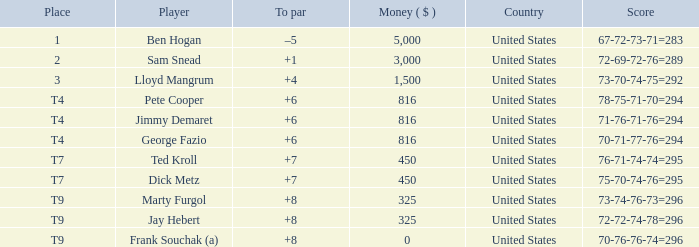Parse the full table. {'header': ['Place', 'Player', 'To par', 'Money ( $ )', 'Country', 'Score'], 'rows': [['1', 'Ben Hogan', '–5', '5,000', 'United States', '67-72-73-71=283'], ['2', 'Sam Snead', '+1', '3,000', 'United States', '72-69-72-76=289'], ['3', 'Lloyd Mangrum', '+4', '1,500', 'United States', '73-70-74-75=292'], ['T4', 'Pete Cooper', '+6', '816', 'United States', '78-75-71-70=294'], ['T4', 'Jimmy Demaret', '+6', '816', 'United States', '71-76-71-76=294'], ['T4', 'George Fazio', '+6', '816', 'United States', '70-71-77-76=294'], ['T7', 'Ted Kroll', '+7', '450', 'United States', '76-71-74-74=295'], ['T7', 'Dick Metz', '+7', '450', 'United States', '75-70-74-76=295'], ['T9', 'Marty Furgol', '+8', '325', 'United States', '73-74-76-73=296'], ['T9', 'Jay Hebert', '+8', '325', 'United States', '72-72-74-78=296'], ['T9', 'Frank Souchak (a)', '+8', '0', 'United States', '70-76-76-74=296']]} How much was paid to the player whose score was 70-71-77-76=294? 816.0. 